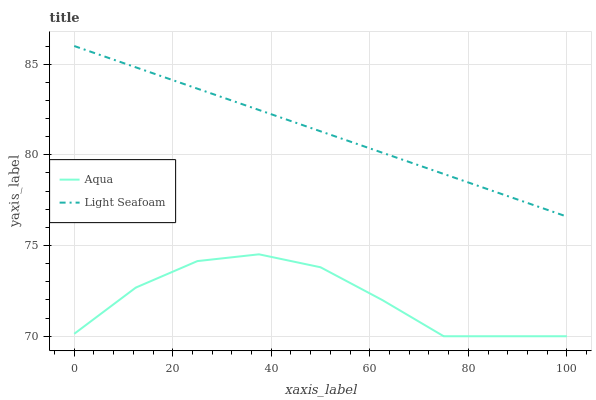Does Aqua have the minimum area under the curve?
Answer yes or no. Yes. Does Light Seafoam have the maximum area under the curve?
Answer yes or no. Yes. Does Aqua have the maximum area under the curve?
Answer yes or no. No. Is Light Seafoam the smoothest?
Answer yes or no. Yes. Is Aqua the roughest?
Answer yes or no. Yes. Is Aqua the smoothest?
Answer yes or no. No. Does Aqua have the lowest value?
Answer yes or no. Yes. Does Light Seafoam have the highest value?
Answer yes or no. Yes. Does Aqua have the highest value?
Answer yes or no. No. Is Aqua less than Light Seafoam?
Answer yes or no. Yes. Is Light Seafoam greater than Aqua?
Answer yes or no. Yes. Does Aqua intersect Light Seafoam?
Answer yes or no. No. 